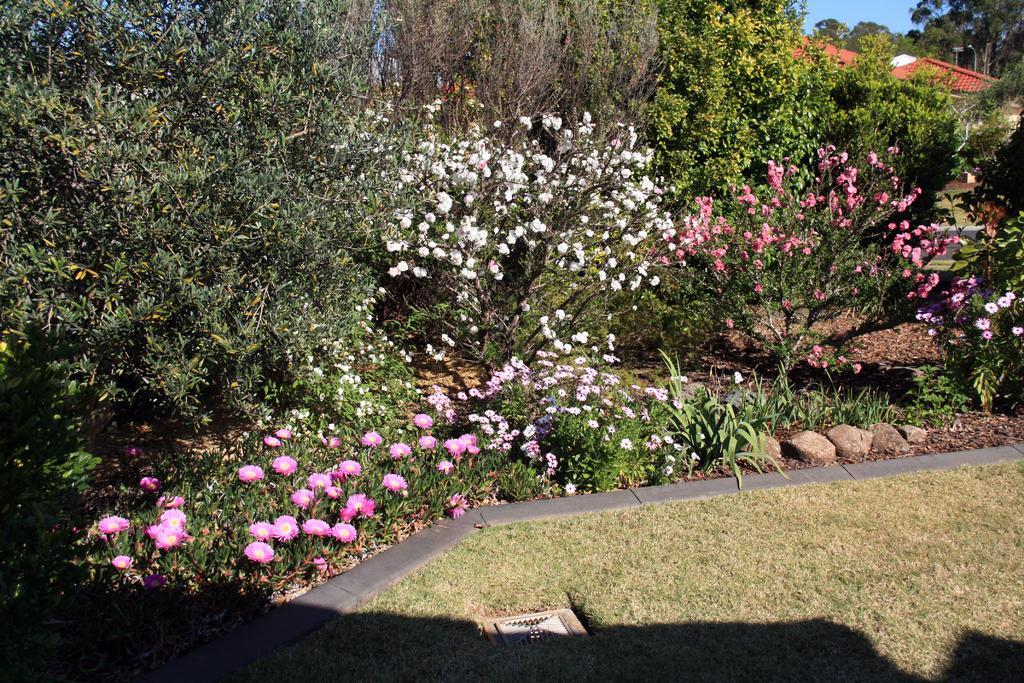Please provide a concise description of this image. In this image I can see few trees, houses, small stones, few flowers in pink, white and peach color. The sky is in blue color. 